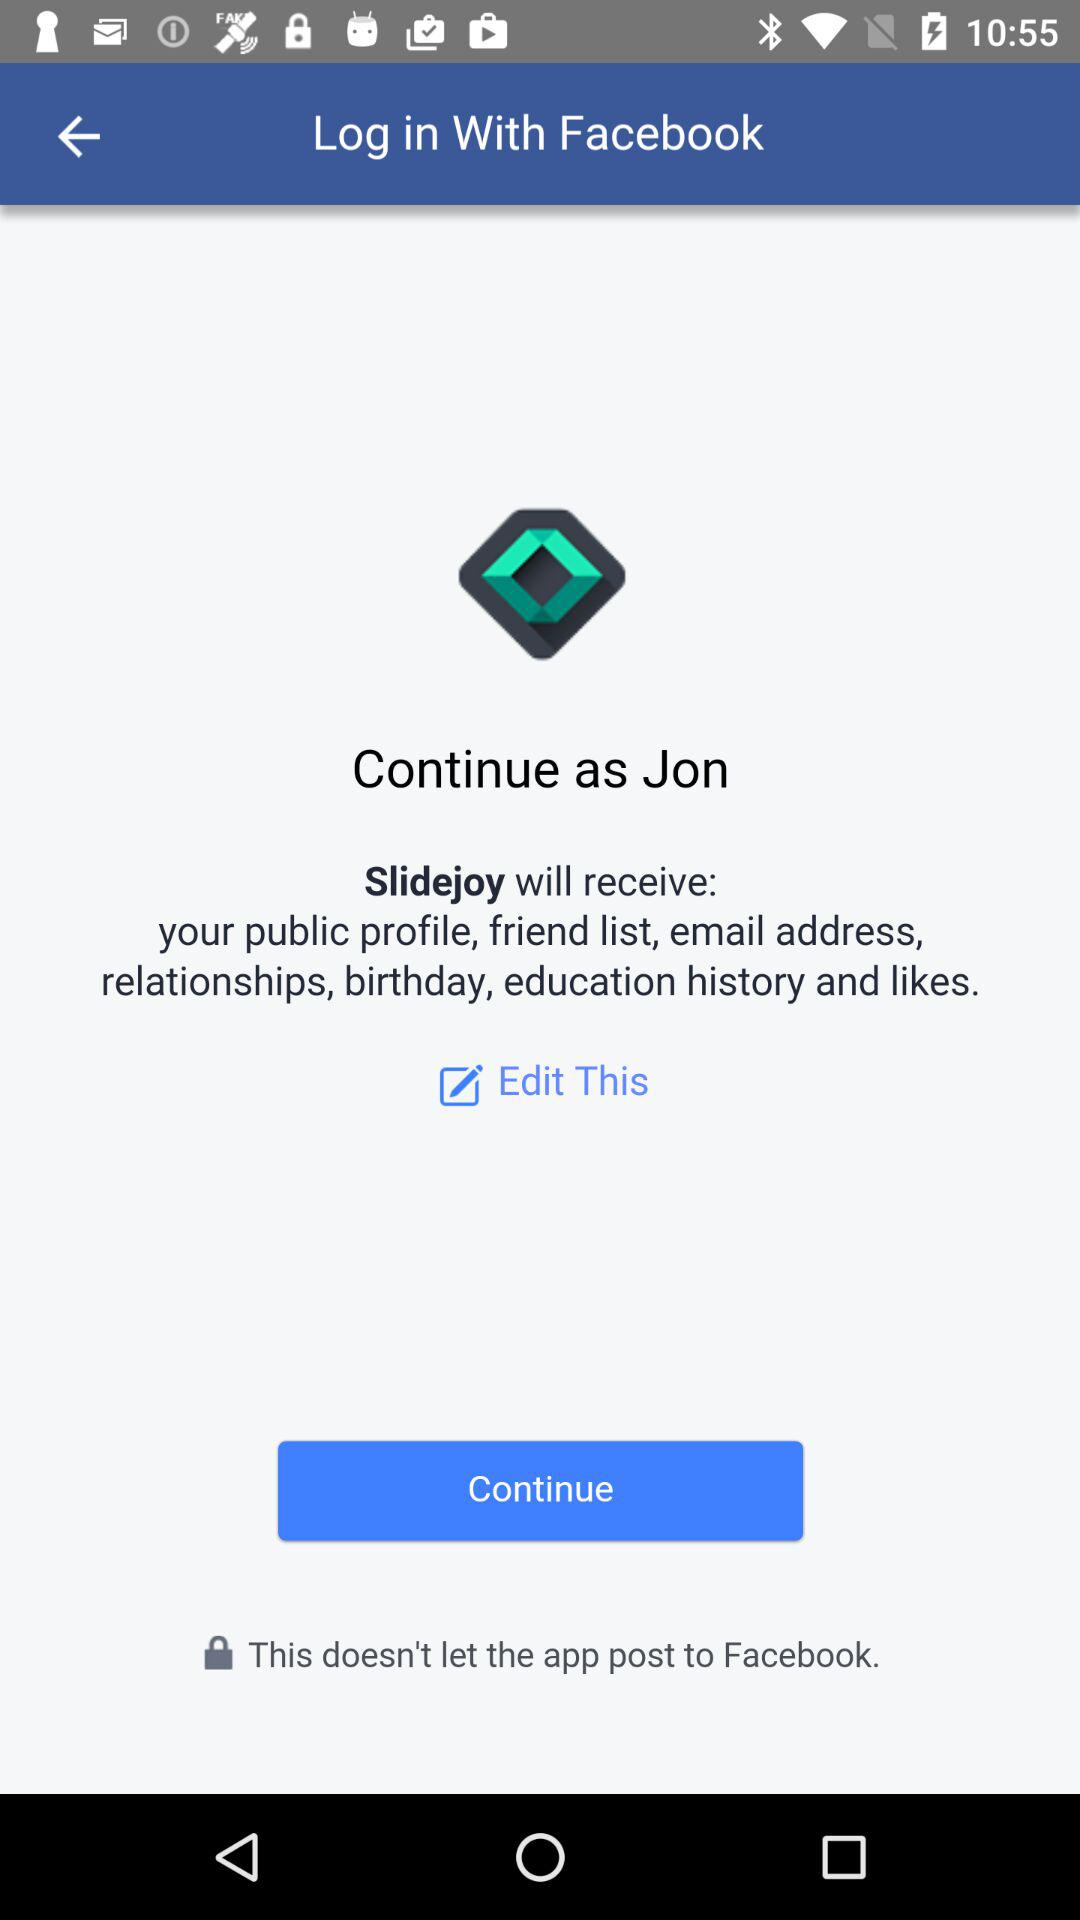Which information will "Slidejoy" receive? "Slidejoy" will receive public profile, friend list, email address, relationships, birthday, education history and likes. 